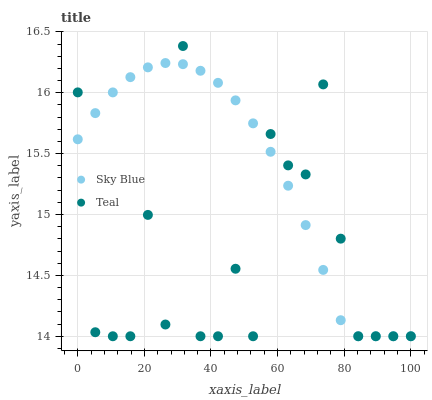Does Teal have the minimum area under the curve?
Answer yes or no. Yes. Does Sky Blue have the maximum area under the curve?
Answer yes or no. Yes. Does Teal have the maximum area under the curve?
Answer yes or no. No. Is Sky Blue the smoothest?
Answer yes or no. Yes. Is Teal the roughest?
Answer yes or no. Yes. Is Teal the smoothest?
Answer yes or no. No. Does Sky Blue have the lowest value?
Answer yes or no. Yes. Does Teal have the highest value?
Answer yes or no. Yes. Does Sky Blue intersect Teal?
Answer yes or no. Yes. Is Sky Blue less than Teal?
Answer yes or no. No. Is Sky Blue greater than Teal?
Answer yes or no. No. 